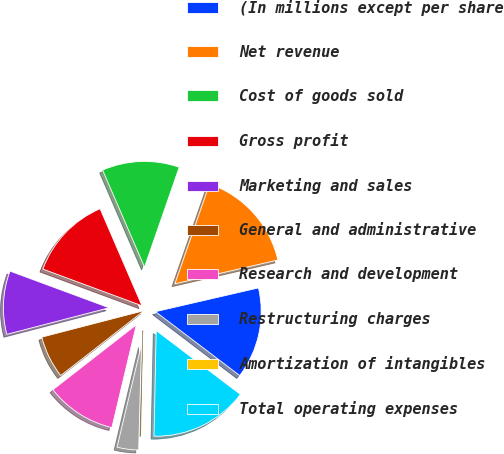Convert chart to OTSL. <chart><loc_0><loc_0><loc_500><loc_500><pie_chart><fcel>(In millions except per share<fcel>Net revenue<fcel>Cost of goods sold<fcel>Gross profit<fcel>Marketing and sales<fcel>General and administrative<fcel>Research and development<fcel>Restructuring charges<fcel>Amortization of intangibles<fcel>Total operating expenses<nl><fcel>13.94%<fcel>16.07%<fcel>11.81%<fcel>12.87%<fcel>9.68%<fcel>6.49%<fcel>10.75%<fcel>3.29%<fcel>0.1%<fcel>15.0%<nl></chart> 